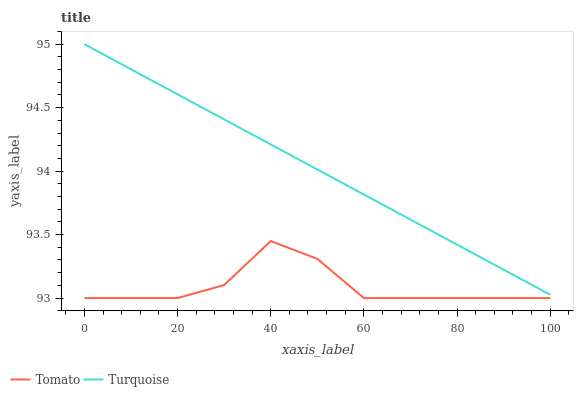Does Tomato have the minimum area under the curve?
Answer yes or no. Yes. Does Turquoise have the maximum area under the curve?
Answer yes or no. Yes. Does Turquoise have the minimum area under the curve?
Answer yes or no. No. Is Turquoise the smoothest?
Answer yes or no. Yes. Is Tomato the roughest?
Answer yes or no. Yes. Is Turquoise the roughest?
Answer yes or no. No. Does Tomato have the lowest value?
Answer yes or no. Yes. Does Turquoise have the lowest value?
Answer yes or no. No. Does Turquoise have the highest value?
Answer yes or no. Yes. Is Tomato less than Turquoise?
Answer yes or no. Yes. Is Turquoise greater than Tomato?
Answer yes or no. Yes. Does Tomato intersect Turquoise?
Answer yes or no. No. 